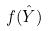<formula> <loc_0><loc_0><loc_500><loc_500>f ( \hat { Y } )</formula> 